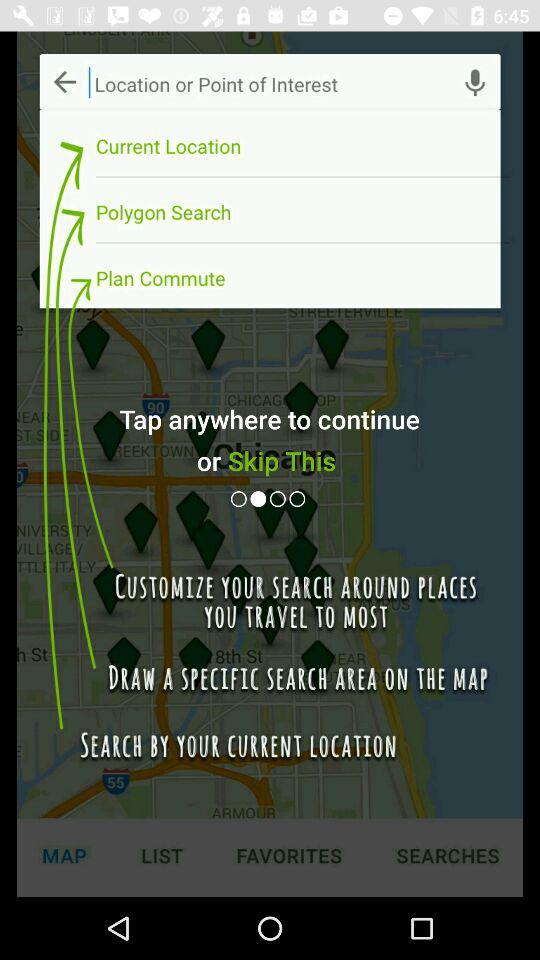Which tab is selected? The selected tab is "MAP". 